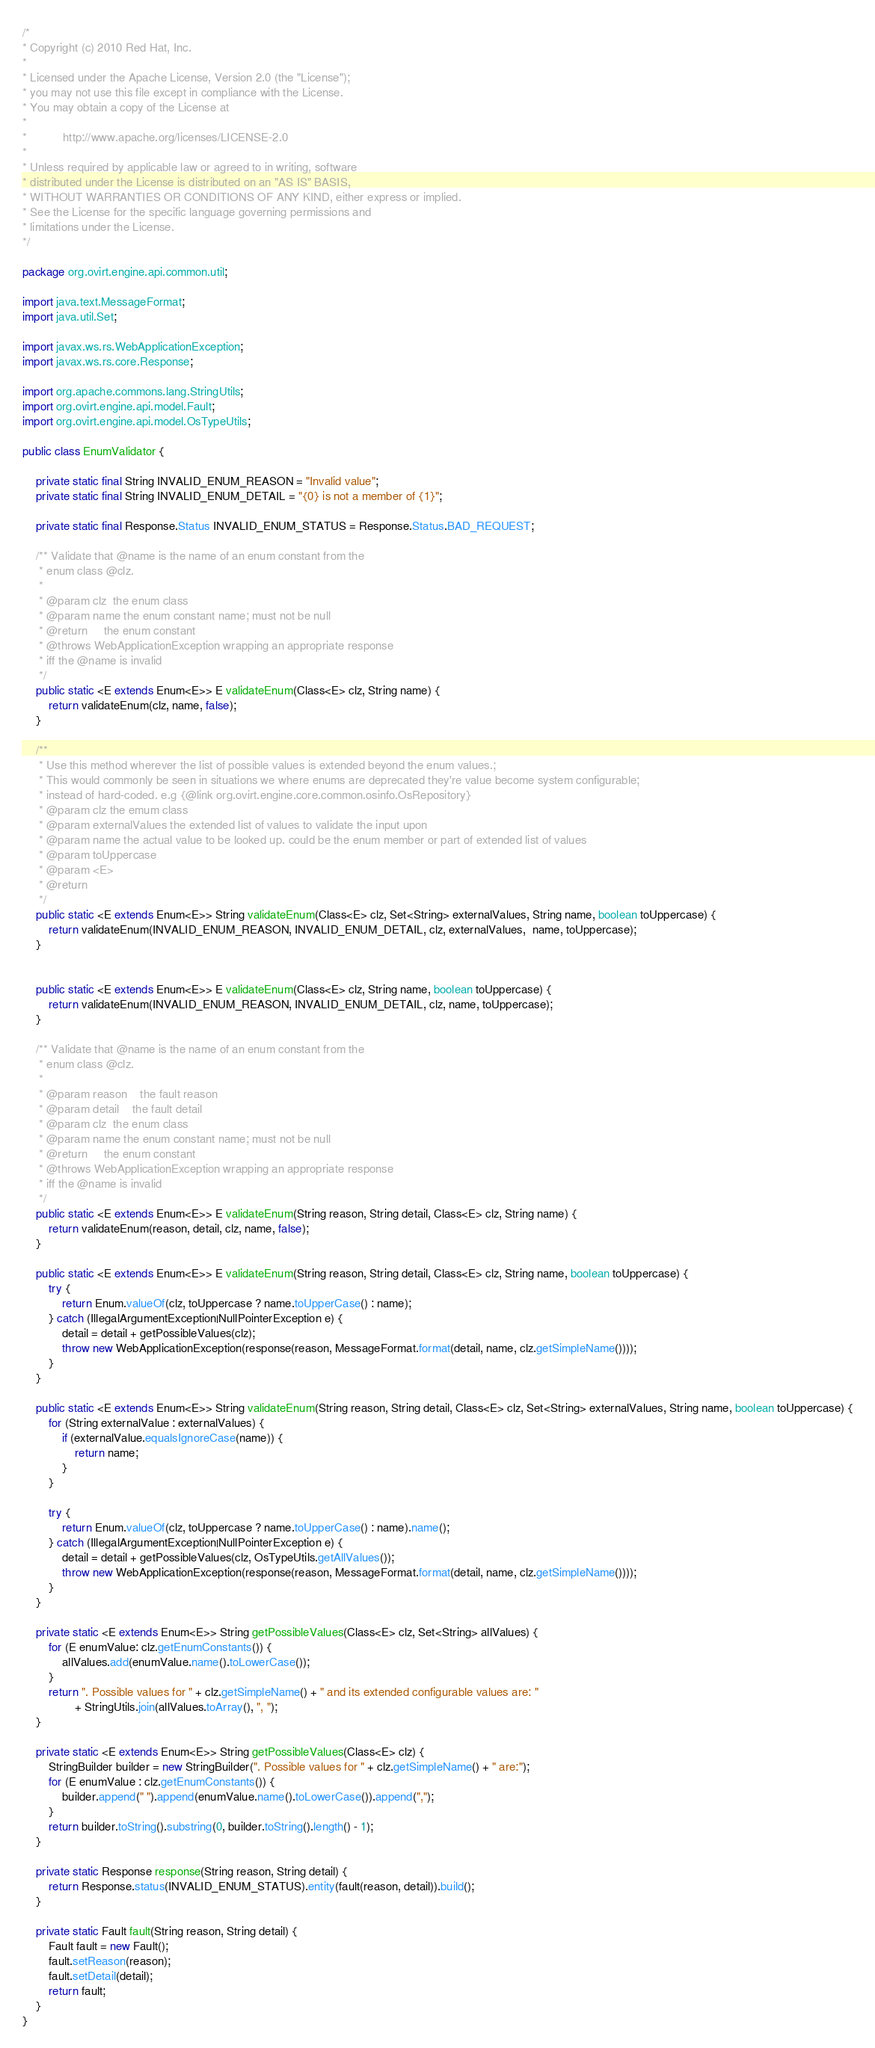<code> <loc_0><loc_0><loc_500><loc_500><_Java_>/*
* Copyright (c) 2010 Red Hat, Inc.
*
* Licensed under the Apache License, Version 2.0 (the "License");
* you may not use this file except in compliance with the License.
* You may obtain a copy of the License at
*
*           http://www.apache.org/licenses/LICENSE-2.0
*
* Unless required by applicable law or agreed to in writing, software
* distributed under the License is distributed on an "AS IS" BASIS,
* WITHOUT WARRANTIES OR CONDITIONS OF ANY KIND, either express or implied.
* See the License for the specific language governing permissions and
* limitations under the License.
*/

package org.ovirt.engine.api.common.util;

import java.text.MessageFormat;
import java.util.Set;

import javax.ws.rs.WebApplicationException;
import javax.ws.rs.core.Response;

import org.apache.commons.lang.StringUtils;
import org.ovirt.engine.api.model.Fault;
import org.ovirt.engine.api.model.OsTypeUtils;

public class EnumValidator {

    private static final String INVALID_ENUM_REASON = "Invalid value";
    private static final String INVALID_ENUM_DETAIL = "{0} is not a member of {1}";

    private static final Response.Status INVALID_ENUM_STATUS = Response.Status.BAD_REQUEST;

    /** Validate that @name is the name of an enum constant from the
     * enum class @clz.
     *
     * @param clz  the enum class
     * @param name the enum constant name; must not be null
     * @return     the enum constant
     * @throws WebApplicationException wrapping an appropriate response
     * iff the @name is invalid
     */
    public static <E extends Enum<E>> E validateEnum(Class<E> clz, String name) {
        return validateEnum(clz, name, false);
    }

    /**
     * Use this method wherever the list of possible values is extended beyond the enum values.;
     * This would commonly be seen in situations we where enums are deprecated they're value become system configurable;
     * instead of hard-coded. e.g {@link org.ovirt.engine.core.common.osinfo.OsRepository}
     * @param clz the emum class
     * @param externalValues the extended list of values to validate the input upon
     * @param name the actual value to be looked up. could be the enum member or part of extended list of values
     * @param toUppercase
     * @param <E>
     * @return
     */
    public static <E extends Enum<E>> String validateEnum(Class<E> clz, Set<String> externalValues, String name, boolean toUppercase) {
        return validateEnum(INVALID_ENUM_REASON, INVALID_ENUM_DETAIL, clz, externalValues,  name, toUppercase);
    }


    public static <E extends Enum<E>> E validateEnum(Class<E> clz, String name, boolean toUppercase) {
        return validateEnum(INVALID_ENUM_REASON, INVALID_ENUM_DETAIL, clz, name, toUppercase);
    }

    /** Validate that @name is the name of an enum constant from the
     * enum class @clz.
     *
     * @param reason    the fault reason
     * @param detail    the fault detail
     * @param clz  the enum class
     * @param name the enum constant name; must not be null
     * @return     the enum constant
     * @throws WebApplicationException wrapping an appropriate response
     * iff the @name is invalid
     */
    public static <E extends Enum<E>> E validateEnum(String reason, String detail, Class<E> clz, String name) {
        return validateEnum(reason, detail, clz, name, false);
    }

    public static <E extends Enum<E>> E validateEnum(String reason, String detail, Class<E> clz, String name, boolean toUppercase) {
        try {
            return Enum.valueOf(clz, toUppercase ? name.toUpperCase() : name);
        } catch (IllegalArgumentException|NullPointerException e) {
            detail = detail + getPossibleValues(clz);
            throw new WebApplicationException(response(reason, MessageFormat.format(detail, name, clz.getSimpleName())));
        }
    }

    public static <E extends Enum<E>> String validateEnum(String reason, String detail, Class<E> clz, Set<String> externalValues, String name, boolean toUppercase) {
        for (String externalValue : externalValues) {
            if (externalValue.equalsIgnoreCase(name)) {
                return name;
            }
        }

        try {
            return Enum.valueOf(clz, toUppercase ? name.toUpperCase() : name).name();
        } catch (IllegalArgumentException|NullPointerException e) {
            detail = detail + getPossibleValues(clz, OsTypeUtils.getAllValues());
            throw new WebApplicationException(response(reason, MessageFormat.format(detail, name, clz.getSimpleName())));
        }
    }

    private static <E extends Enum<E>> String getPossibleValues(Class<E> clz, Set<String> allValues) {
        for (E enumValue: clz.getEnumConstants()) {
            allValues.add(enumValue.name().toLowerCase());
        }
        return ". Possible values for " + clz.getSimpleName() + " and its extended configurable values are: "
                + StringUtils.join(allValues.toArray(), ", ");
    }

    private static <E extends Enum<E>> String getPossibleValues(Class<E> clz) {
        StringBuilder builder = new StringBuilder(". Possible values for " + clz.getSimpleName() + " are:");
        for (E enumValue : clz.getEnumConstants()) {
            builder.append(" ").append(enumValue.name().toLowerCase()).append(",");
        }
        return builder.toString().substring(0, builder.toString().length() - 1);
    }

    private static Response response(String reason, String detail) {
        return Response.status(INVALID_ENUM_STATUS).entity(fault(reason, detail)).build();
    }

    private static Fault fault(String reason, String detail) {
        Fault fault = new Fault();
        fault.setReason(reason);
        fault.setDetail(detail);
        return fault;
    }
}
</code> 